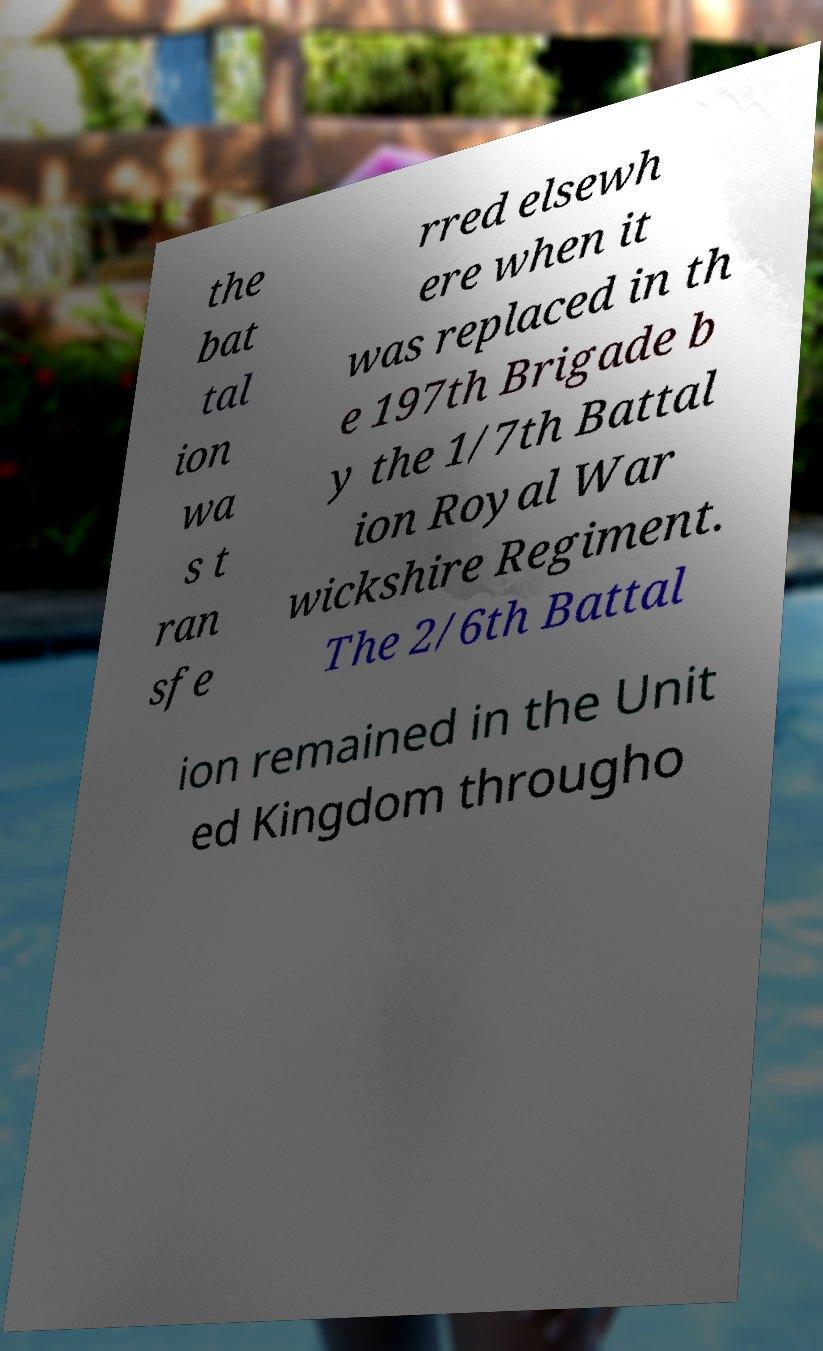Please read and relay the text visible in this image. What does it say? the bat tal ion wa s t ran sfe rred elsewh ere when it was replaced in th e 197th Brigade b y the 1/7th Battal ion Royal War wickshire Regiment. The 2/6th Battal ion remained in the Unit ed Kingdom througho 